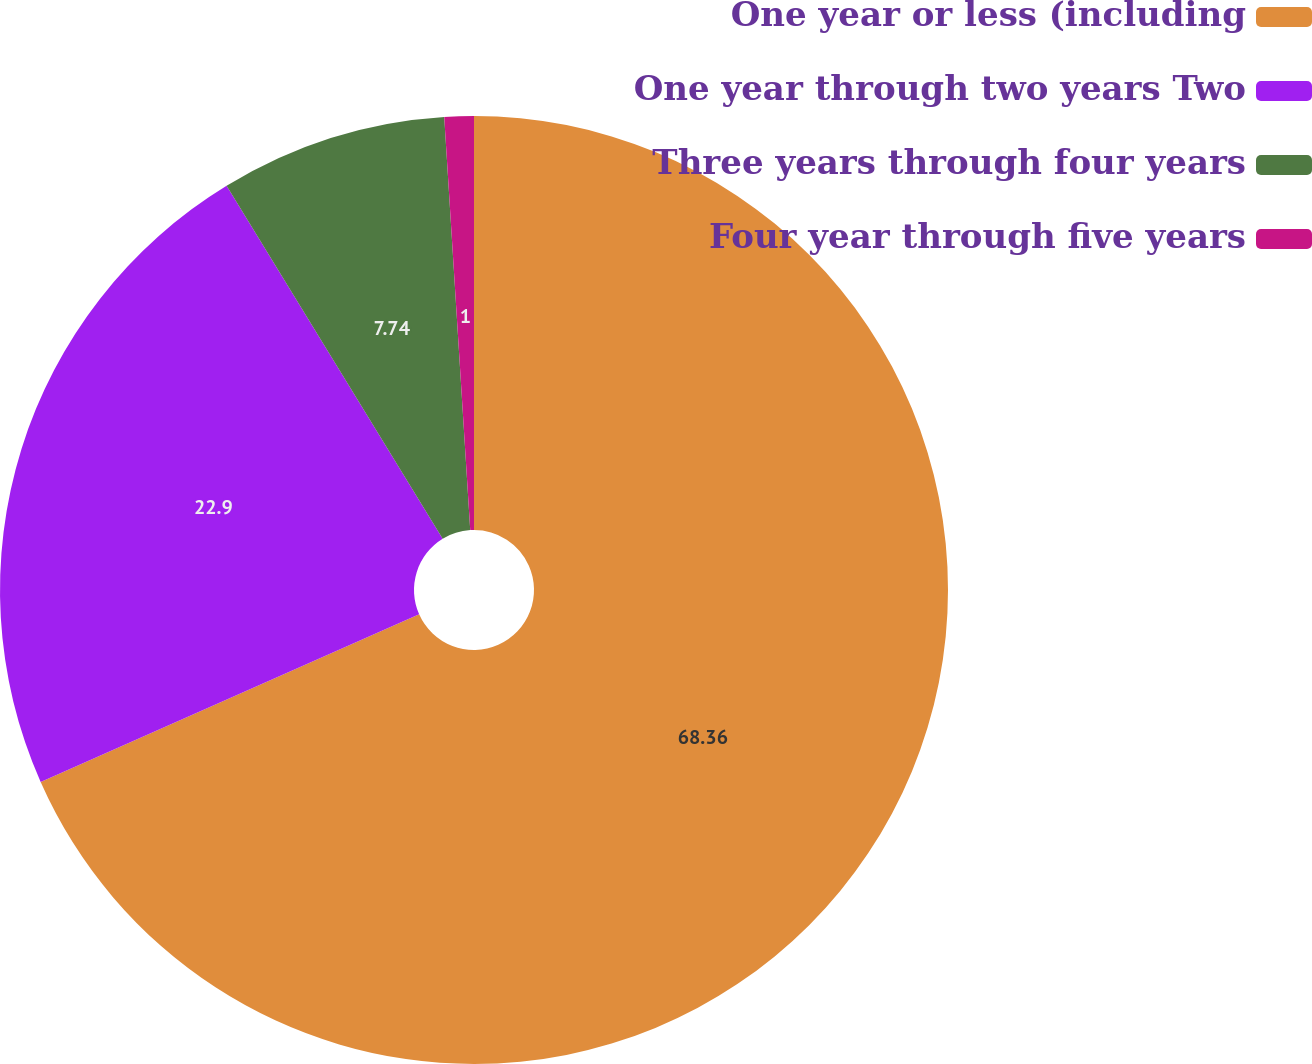Convert chart. <chart><loc_0><loc_0><loc_500><loc_500><pie_chart><fcel>One year or less (including<fcel>One year through two years Two<fcel>Three years through four years<fcel>Four year through five years<nl><fcel>68.36%<fcel>22.9%<fcel>7.74%<fcel>1.0%<nl></chart> 